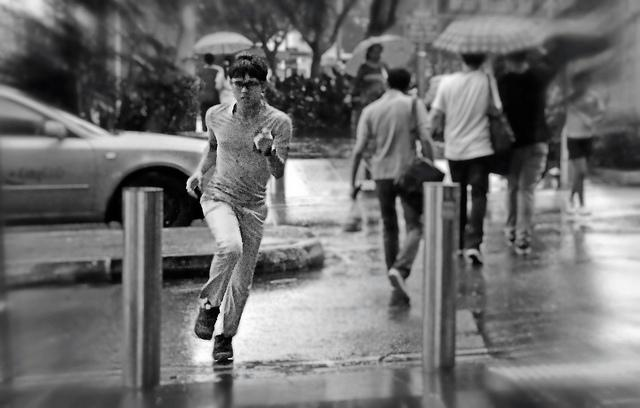What is the boy running through? rain 